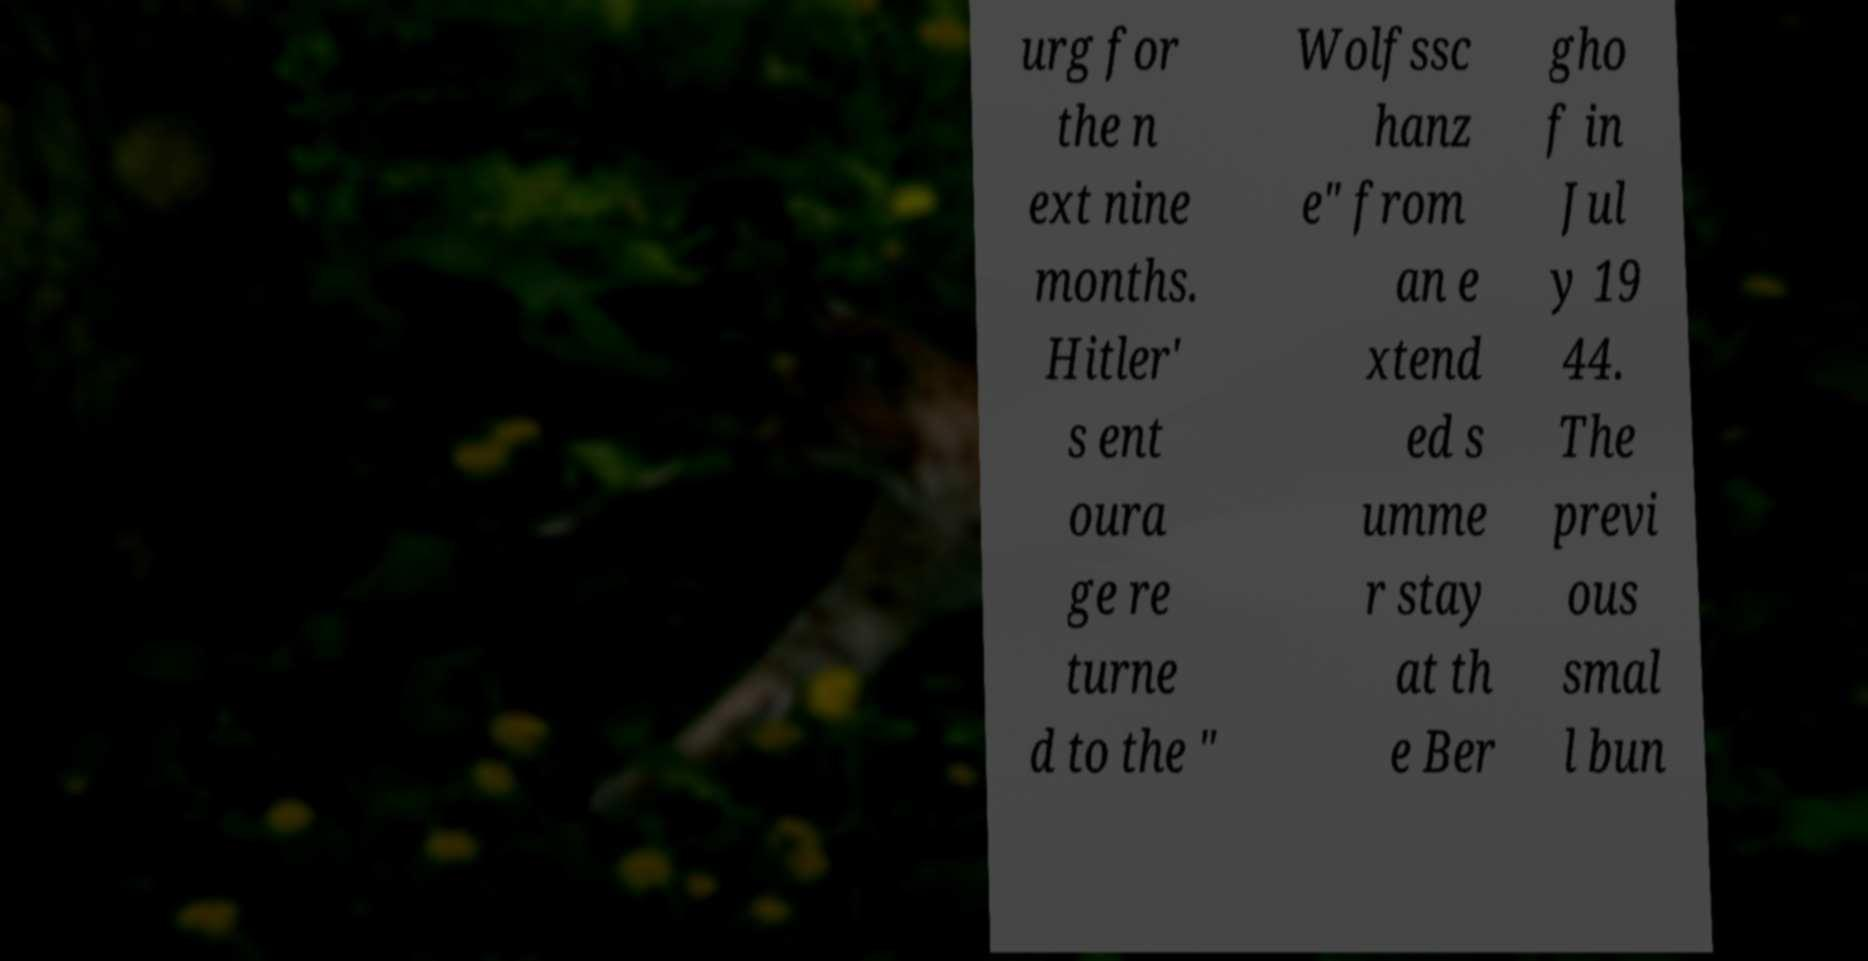Can you accurately transcribe the text from the provided image for me? urg for the n ext nine months. Hitler' s ent oura ge re turne d to the " Wolfssc hanz e" from an e xtend ed s umme r stay at th e Ber gho f in Jul y 19 44. The previ ous smal l bun 